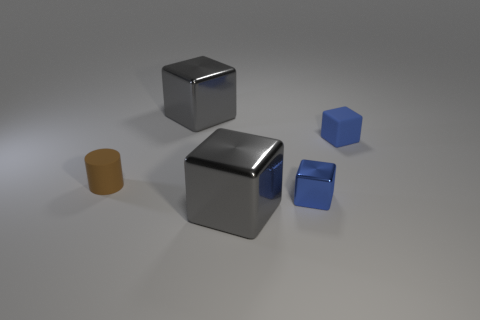Subtract all matte blocks. How many blocks are left? 3 Subtract all green cubes. Subtract all purple cylinders. How many cubes are left? 4 Add 5 big gray objects. How many objects exist? 10 Subtract all cubes. How many objects are left? 1 Subtract all cylinders. Subtract all blue matte things. How many objects are left? 3 Add 5 gray shiny objects. How many gray shiny objects are left? 7 Add 2 small brown metal cylinders. How many small brown metal cylinders exist? 2 Subtract 0 brown blocks. How many objects are left? 5 